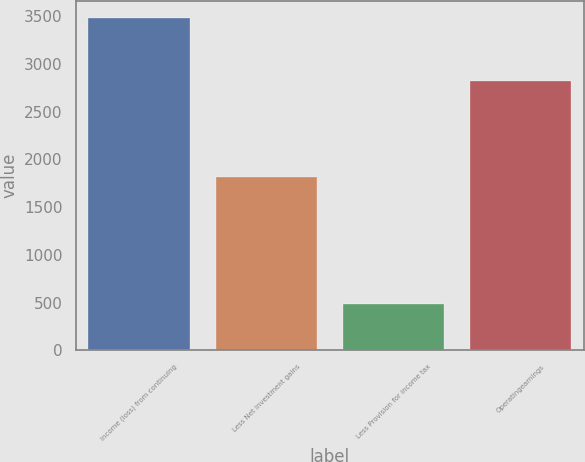Convert chart to OTSL. <chart><loc_0><loc_0><loc_500><loc_500><bar_chart><fcel>Income (loss) from continuing<fcel>Less Net investment gains<fcel>Less Provision for income tax<fcel>Operatingearnings<nl><fcel>3481<fcel>1812<fcel>488<fcel>2819<nl></chart> 